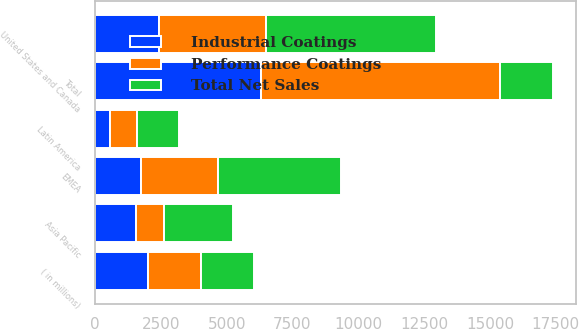Convert chart to OTSL. <chart><loc_0><loc_0><loc_500><loc_500><stacked_bar_chart><ecel><fcel>( in millions)<fcel>United States and Canada<fcel>EMEA<fcel>Asia Pacific<fcel>Latin America<fcel>Total<nl><fcel>Performance Coatings<fcel>2018<fcel>4062<fcel>2936<fcel>1071<fcel>1018<fcel>9087<nl><fcel>Industrial Coatings<fcel>2018<fcel>2423<fcel>1742<fcel>1547<fcel>575<fcel>6287<nl><fcel>Total Net Sales<fcel>2018<fcel>6485<fcel>4678<fcel>2618<fcel>1593<fcel>2018<nl></chart> 